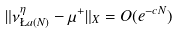<formula> <loc_0><loc_0><loc_500><loc_500>\| \nu _ { \L a ( N ) } ^ { \eta } - \mu ^ { + } \| _ { X } = O ( e ^ { - c N } )</formula> 